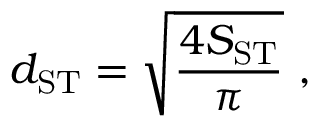<formula> <loc_0><loc_0><loc_500><loc_500>d _ { S T } = \sqrt { \frac { 4 S _ { S T } } { \pi } } ,</formula> 